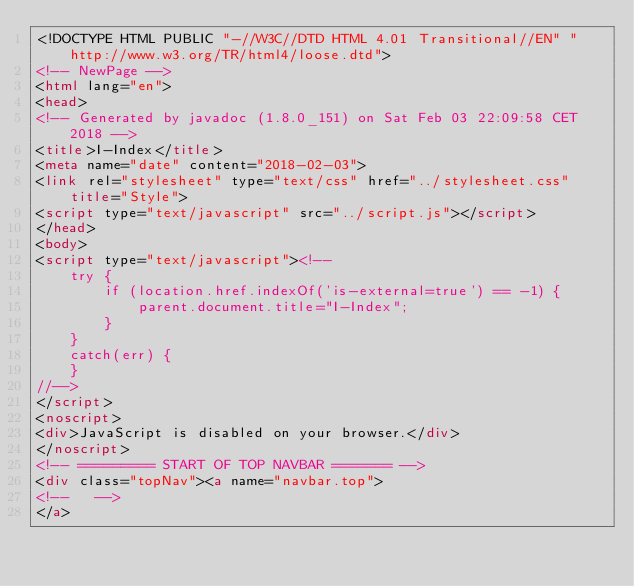<code> <loc_0><loc_0><loc_500><loc_500><_HTML_><!DOCTYPE HTML PUBLIC "-//W3C//DTD HTML 4.01 Transitional//EN" "http://www.w3.org/TR/html4/loose.dtd">
<!-- NewPage -->
<html lang="en">
<head>
<!-- Generated by javadoc (1.8.0_151) on Sat Feb 03 22:09:58 CET 2018 -->
<title>I-Index</title>
<meta name="date" content="2018-02-03">
<link rel="stylesheet" type="text/css" href="../stylesheet.css" title="Style">
<script type="text/javascript" src="../script.js"></script>
</head>
<body>
<script type="text/javascript"><!--
    try {
        if (location.href.indexOf('is-external=true') == -1) {
            parent.document.title="I-Index";
        }
    }
    catch(err) {
    }
//-->
</script>
<noscript>
<div>JavaScript is disabled on your browser.</div>
</noscript>
<!-- ========= START OF TOP NAVBAR ======= -->
<div class="topNav"><a name="navbar.top">
<!--   -->
</a></code> 